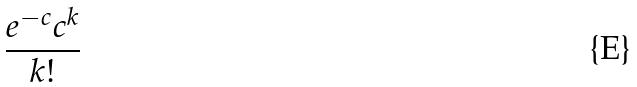Convert formula to latex. <formula><loc_0><loc_0><loc_500><loc_500>\frac { e ^ { - c } c ^ { k } } { k ! }</formula> 